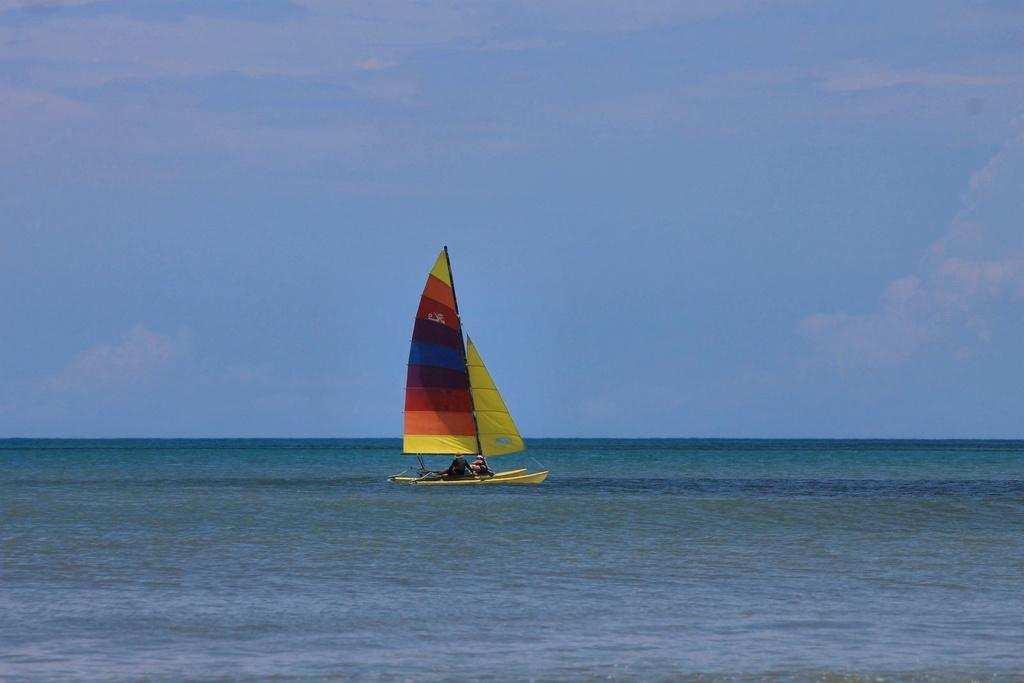What is the main subject of the image? The main subject of the image is a boat. Can you describe the appearance of the boat? The boat is colorful. How many people are on the boat? There are two people on the boat. Where is the boat located? The boat is on the water. What can be seen in the background of the image? There are clouds and a blue sky in the background of the image. What type of growth can be seen in the field behind the boat? There is no field present in the image, so no growth can be observed. 